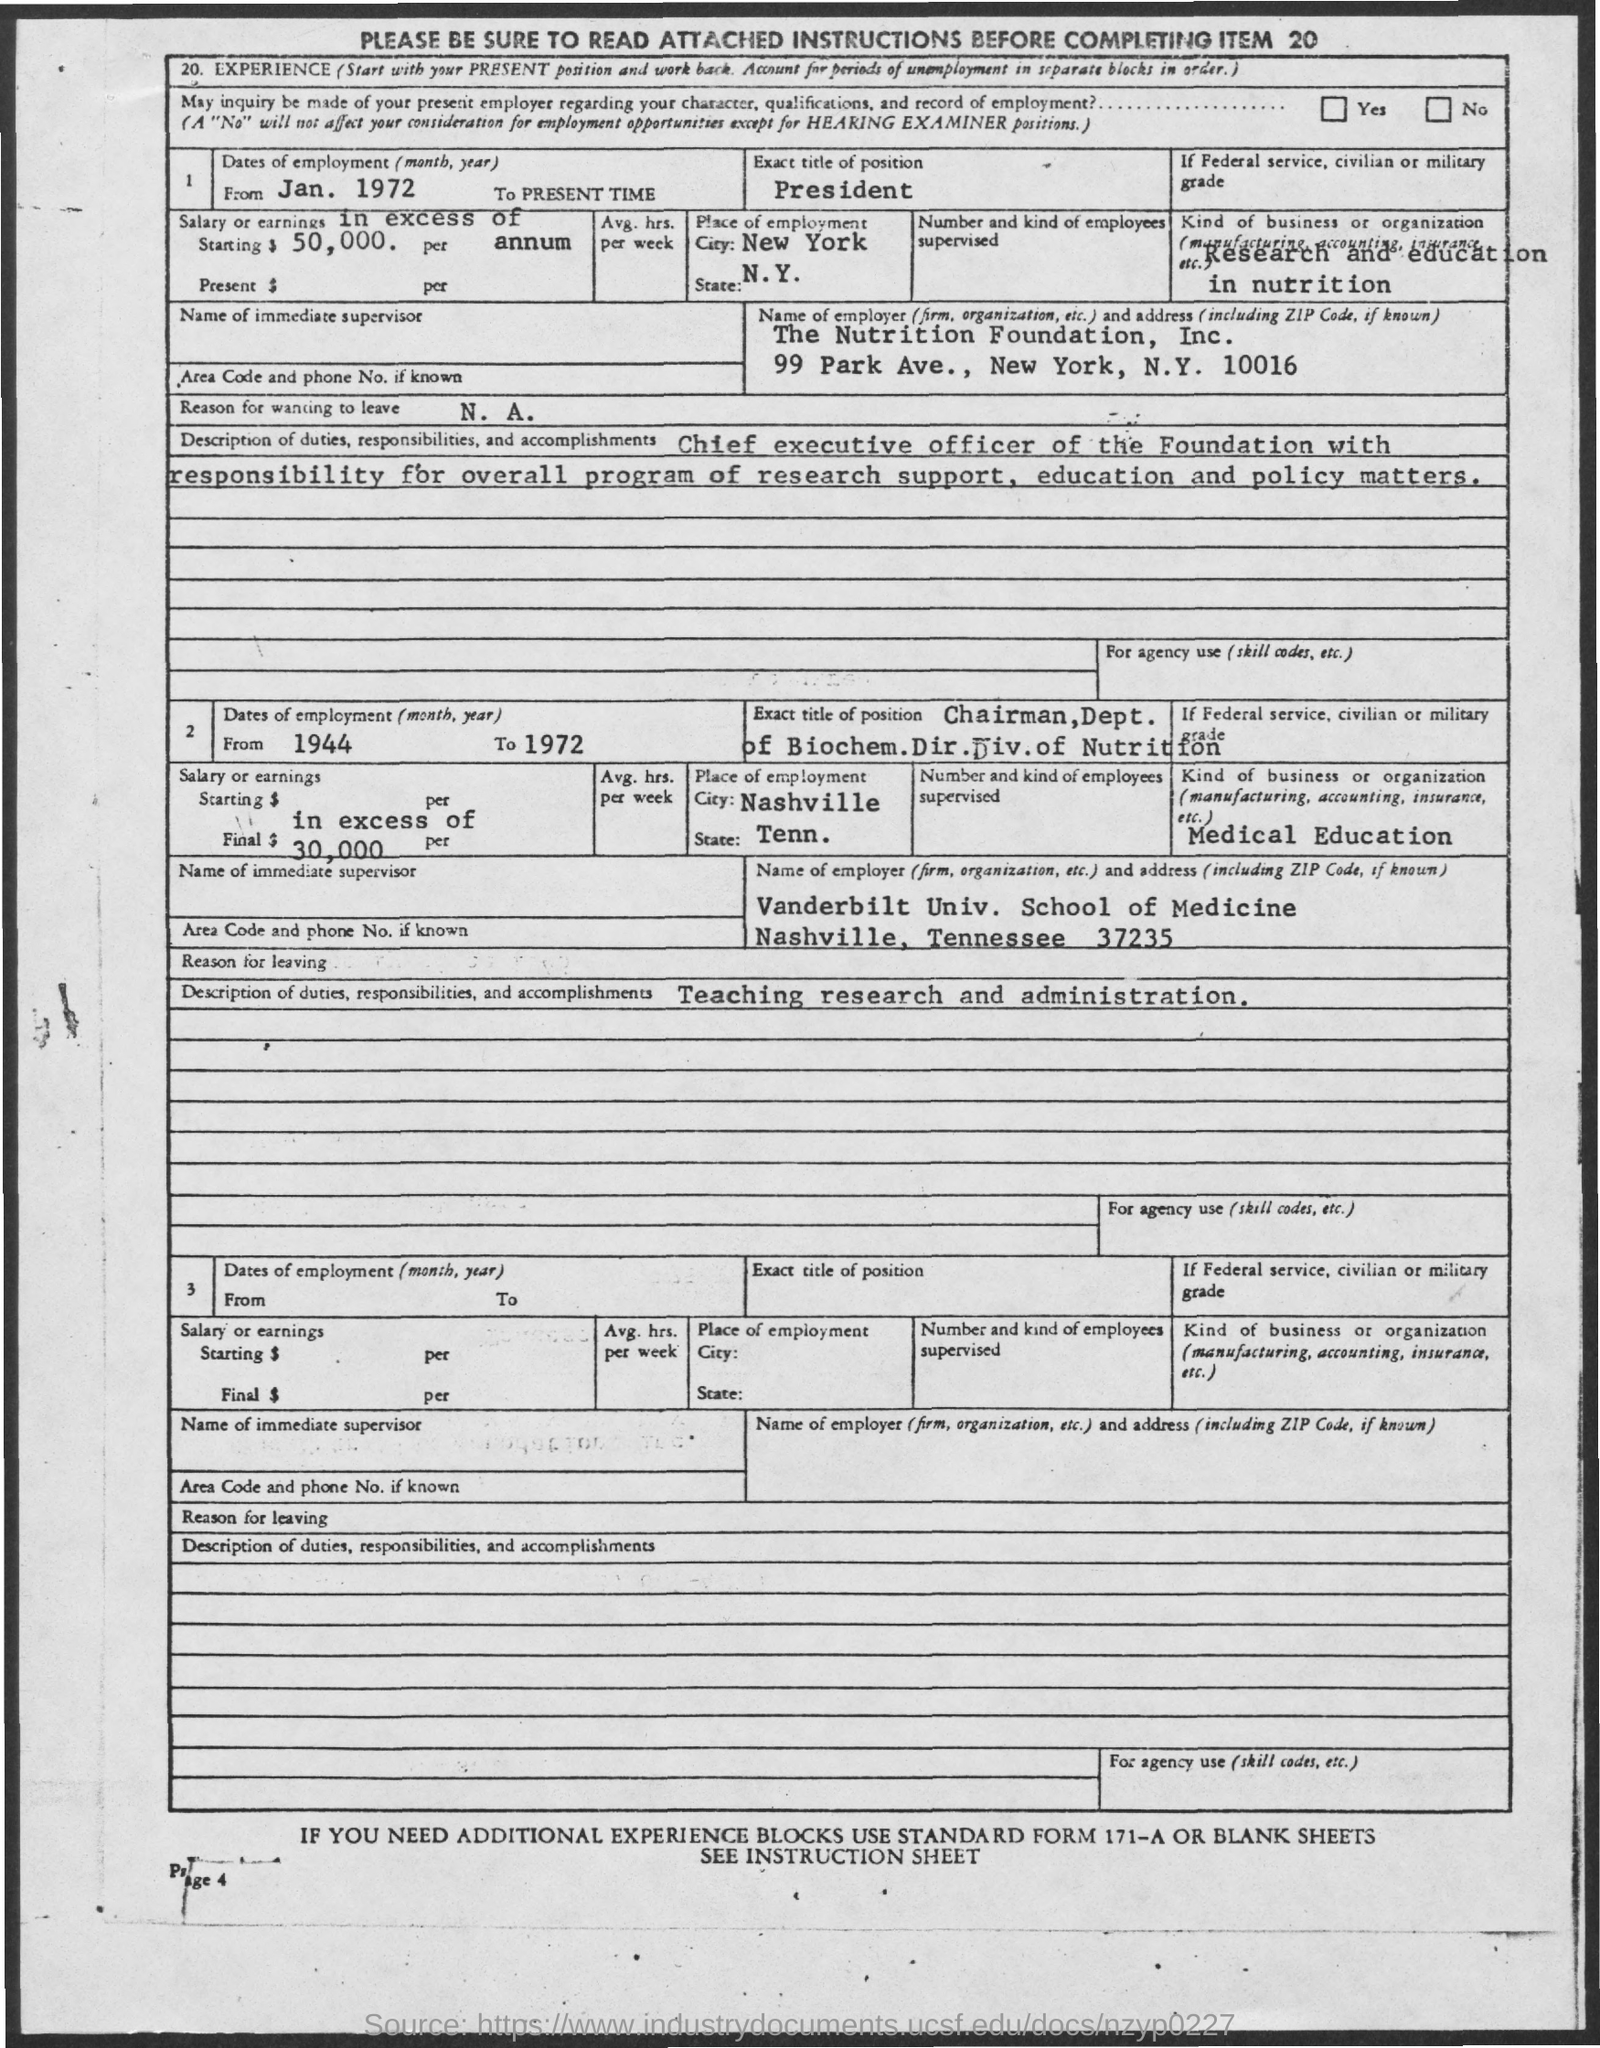Indicate a few pertinent items in this graphic. The Nutrition Foundation, Inc. is located at 99 Park Ave., New York, N.Y. 10016. 